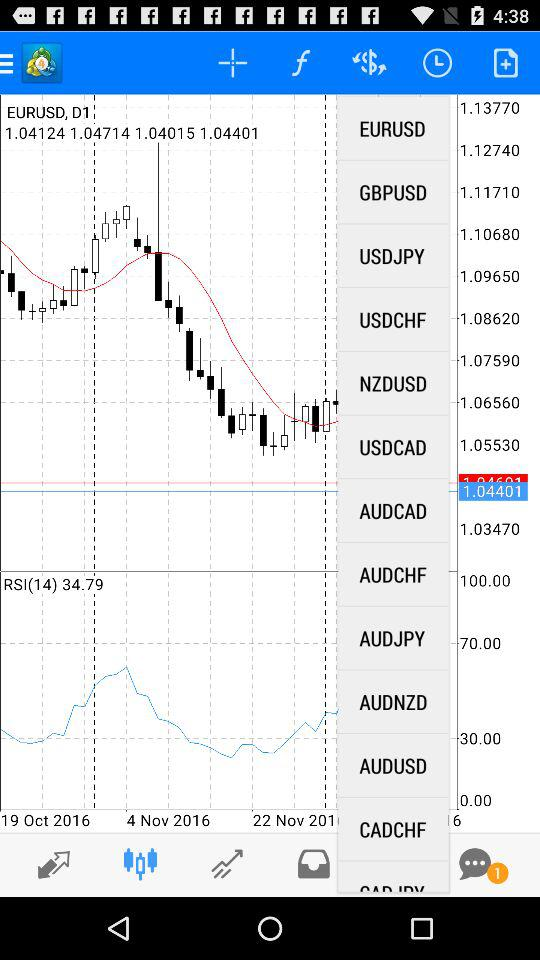Is there any unread message? There is 1 unread message. 